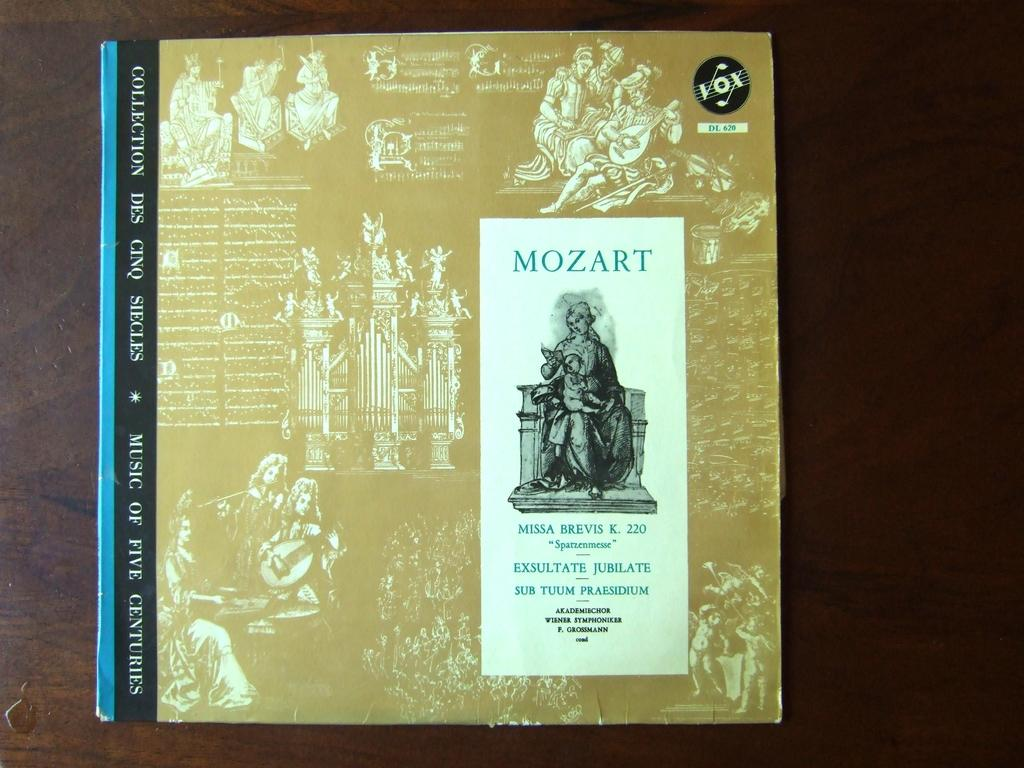<image>
Provide a brief description of the given image. A record featuring Mozart's Missa Brevis K. 220 and other works, presented in dust sleeve with an ornate golden cover. 